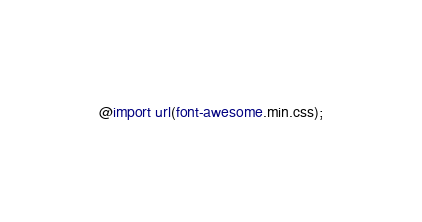<code> <loc_0><loc_0><loc_500><loc_500><_CSS_>@import url(font-awesome.min.css);</code> 